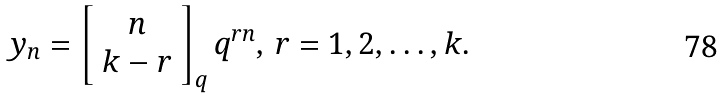<formula> <loc_0><loc_0><loc_500><loc_500>y _ { n } = \left [ \begin{array} { c } n \\ k - r \end{array} \right ] _ { q } q ^ { r n } , \, r = 1 , 2 , \dots , k .</formula> 